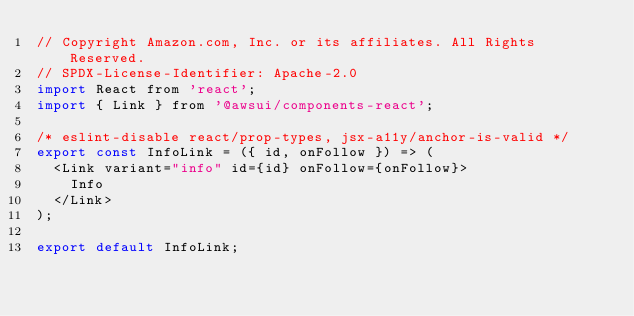Convert code to text. <code><loc_0><loc_0><loc_500><loc_500><_JavaScript_>// Copyright Amazon.com, Inc. or its affiliates. All Rights Reserved.
// SPDX-License-Identifier: Apache-2.0
import React from 'react';
import { Link } from '@awsui/components-react';

/* eslint-disable react/prop-types, jsx-a11y/anchor-is-valid */
export const InfoLink = ({ id, onFollow }) => (
  <Link variant="info" id={id} onFollow={onFollow}>
    Info
  </Link>
);

export default InfoLink;
</code> 